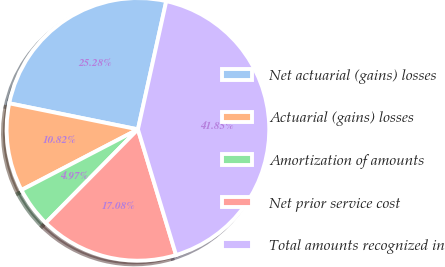<chart> <loc_0><loc_0><loc_500><loc_500><pie_chart><fcel>Net actuarial (gains) losses<fcel>Actuarial (gains) losses<fcel>Amortization of amounts<fcel>Net prior service cost<fcel>Total amounts recognized in<nl><fcel>25.28%<fcel>10.82%<fcel>4.97%<fcel>17.08%<fcel>41.85%<nl></chart> 